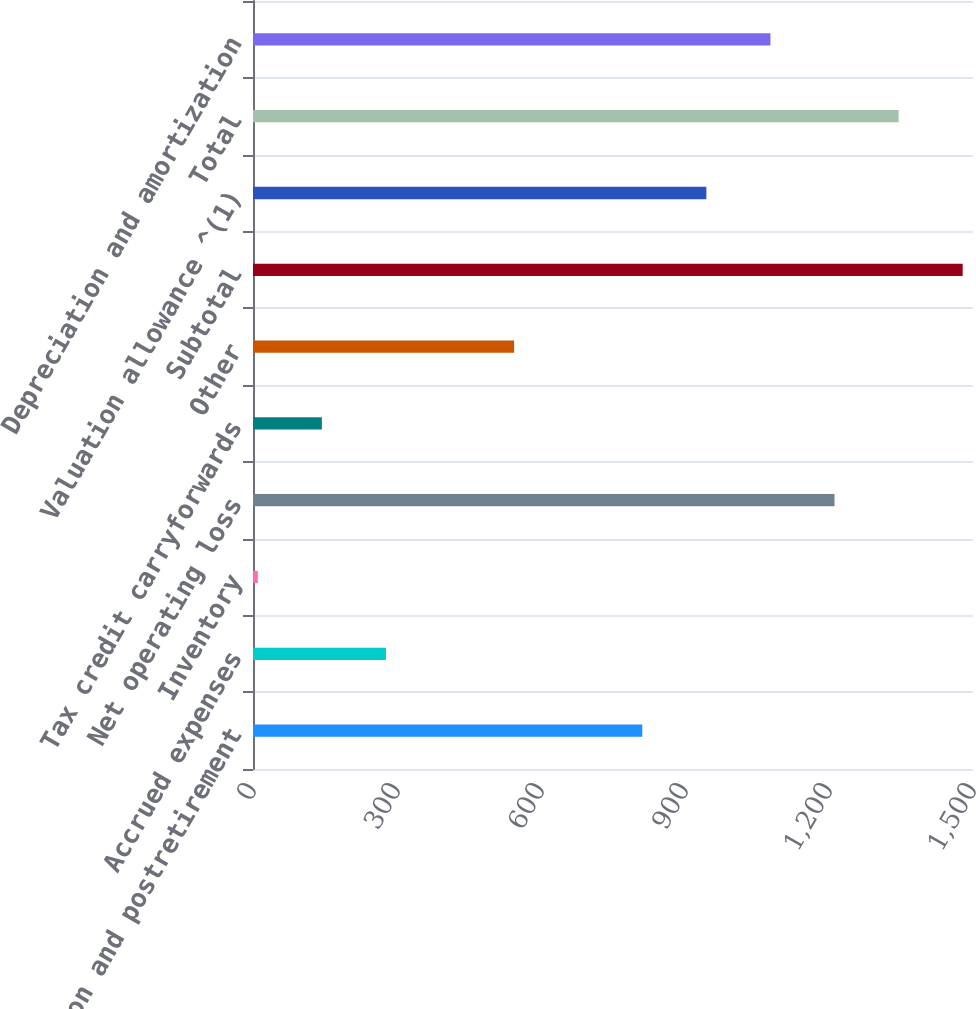Convert chart. <chart><loc_0><loc_0><loc_500><loc_500><bar_chart><fcel>Pension and postretirement<fcel>Accrued expenses<fcel>Inventory<fcel>Net operating loss<fcel>Tax credit carryforwards<fcel>Other<fcel>Subtotal<fcel>Valuation allowance ^(1)<fcel>Total<fcel>Depreciation and amortization<nl><fcel>811<fcel>277<fcel>10<fcel>1211.5<fcel>143.5<fcel>544<fcel>1478.5<fcel>944.5<fcel>1345<fcel>1078<nl></chart> 